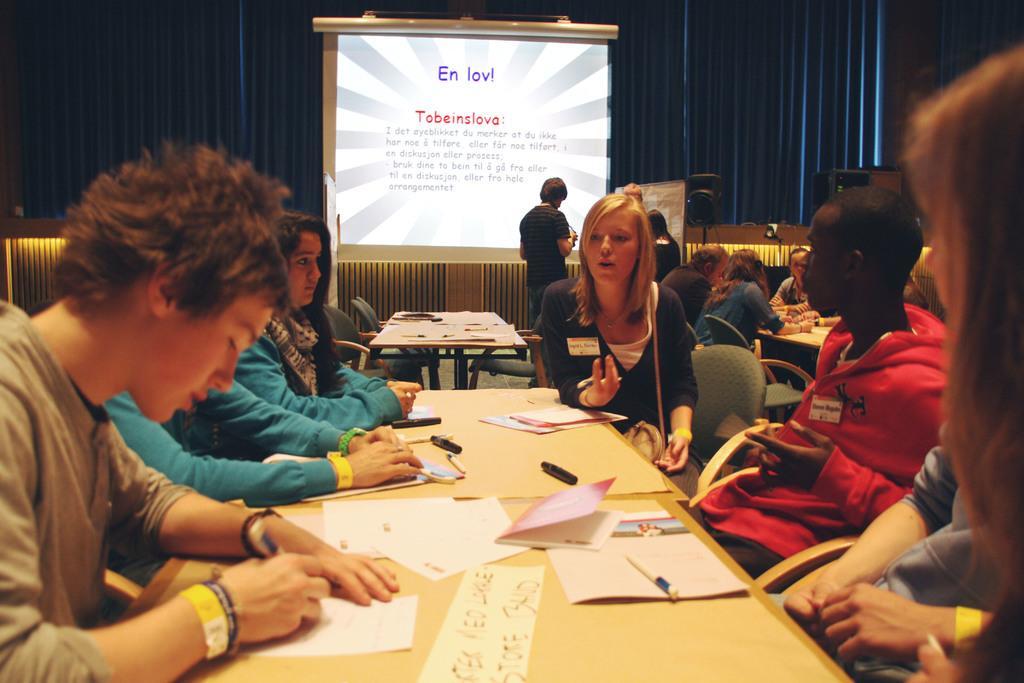Could you give a brief overview of what you see in this image? In this picture I can see there few people sitting at the table and there are writing on the papers. There are a few papers and pens placed on the table. In the backdrop, there are a few more people sitting at the other table, in the backdrop there is a screen and a curtain. 